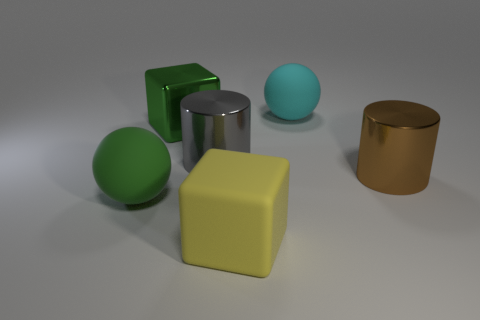There is a thing that is to the right of the green cube and behind the big gray thing; what is its size?
Give a very brief answer. Large. What number of other things are the same shape as the gray thing?
Your answer should be compact. 1. There is another metallic object that is the same shape as the large brown object; what size is it?
Offer a very short reply. Large. Do the big rubber block and the big metal block have the same color?
Provide a short and direct response. No. What color is the big matte object that is on the right side of the gray shiny thing and in front of the big metal block?
Make the answer very short. Yellow. How many objects are either objects that are on the right side of the cyan sphere or big yellow matte blocks?
Your answer should be very brief. 2. There is another large object that is the same shape as the large gray object; what is its color?
Your response must be concise. Brown. Does the large gray thing have the same shape as the large shiny object that is to the right of the cyan thing?
Give a very brief answer. Yes. How many things are either matte things that are behind the large yellow rubber thing or big spheres in front of the green shiny cube?
Your response must be concise. 2. Are there fewer big yellow objects on the left side of the gray object than tiny cyan matte cylinders?
Ensure brevity in your answer.  No. 